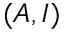<formula> <loc_0><loc_0><loc_500><loc_500>( A , I )</formula> 